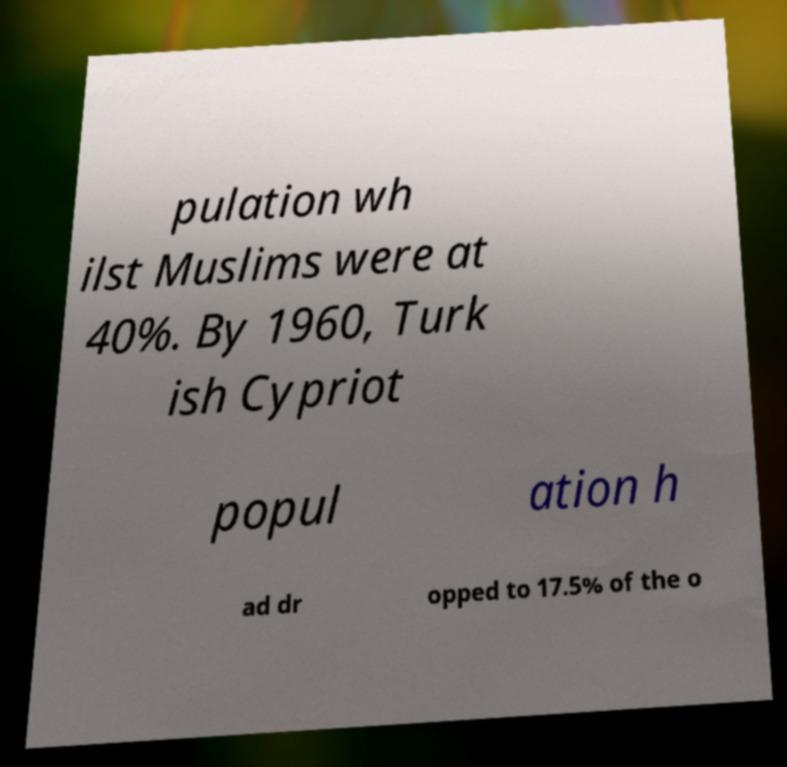Can you accurately transcribe the text from the provided image for me? pulation wh ilst Muslims were at 40%. By 1960, Turk ish Cypriot popul ation h ad dr opped to 17.5% of the o 